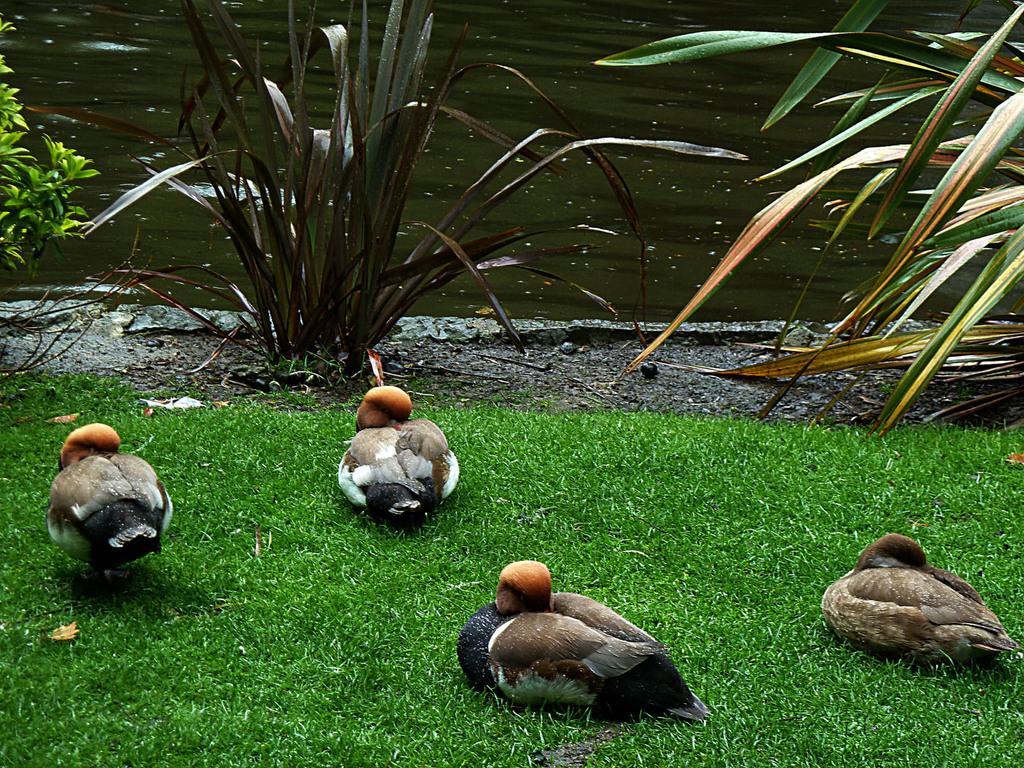How would you summarize this image in a sentence or two? In this image at the bottom there are some birds and grass, and in the background there are some plants and a river. 